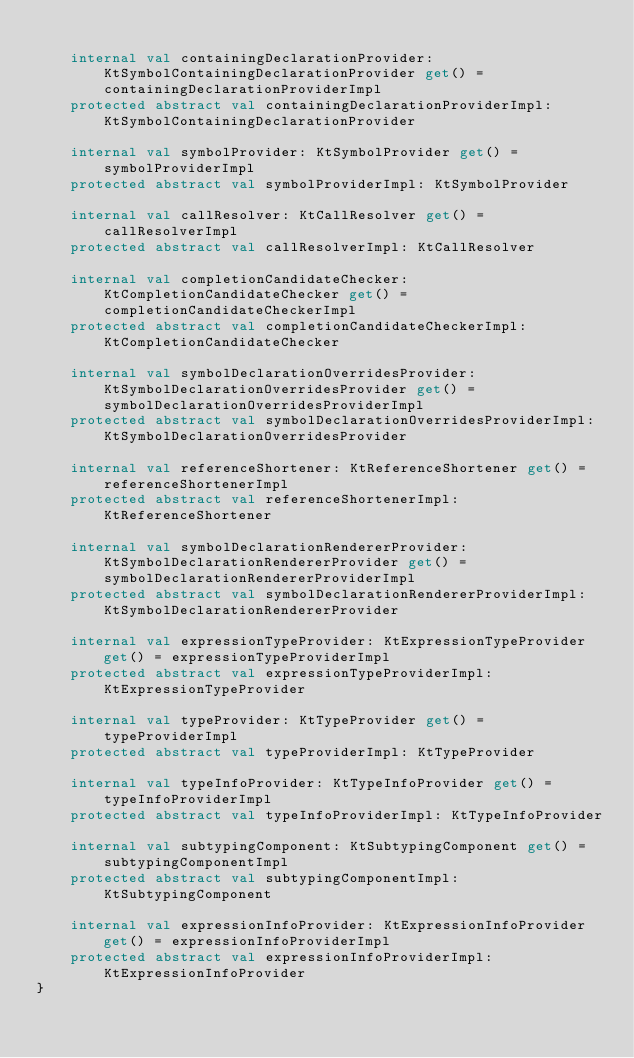Convert code to text. <code><loc_0><loc_0><loc_500><loc_500><_Kotlin_>
    internal val containingDeclarationProvider: KtSymbolContainingDeclarationProvider get() = containingDeclarationProviderImpl
    protected abstract val containingDeclarationProviderImpl: KtSymbolContainingDeclarationProvider

    internal val symbolProvider: KtSymbolProvider get() = symbolProviderImpl
    protected abstract val symbolProviderImpl: KtSymbolProvider

    internal val callResolver: KtCallResolver get() = callResolverImpl
    protected abstract val callResolverImpl: KtCallResolver

    internal val completionCandidateChecker: KtCompletionCandidateChecker get() = completionCandidateCheckerImpl
    protected abstract val completionCandidateCheckerImpl: KtCompletionCandidateChecker

    internal val symbolDeclarationOverridesProvider: KtSymbolDeclarationOverridesProvider get() = symbolDeclarationOverridesProviderImpl
    protected abstract val symbolDeclarationOverridesProviderImpl: KtSymbolDeclarationOverridesProvider

    internal val referenceShortener: KtReferenceShortener get() = referenceShortenerImpl
    protected abstract val referenceShortenerImpl: KtReferenceShortener

    internal val symbolDeclarationRendererProvider: KtSymbolDeclarationRendererProvider get() = symbolDeclarationRendererProviderImpl
    protected abstract val symbolDeclarationRendererProviderImpl: KtSymbolDeclarationRendererProvider

    internal val expressionTypeProvider: KtExpressionTypeProvider get() = expressionTypeProviderImpl
    protected abstract val expressionTypeProviderImpl: KtExpressionTypeProvider

    internal val typeProvider: KtTypeProvider get() = typeProviderImpl
    protected abstract val typeProviderImpl: KtTypeProvider

    internal val typeInfoProvider: KtTypeInfoProvider get() = typeInfoProviderImpl
    protected abstract val typeInfoProviderImpl: KtTypeInfoProvider

    internal val subtypingComponent: KtSubtypingComponent get() = subtypingComponentImpl
    protected abstract val subtypingComponentImpl: KtSubtypingComponent

    internal val expressionInfoProvider: KtExpressionInfoProvider get() = expressionInfoProviderImpl
    protected abstract val expressionInfoProviderImpl: KtExpressionInfoProvider
}</code> 